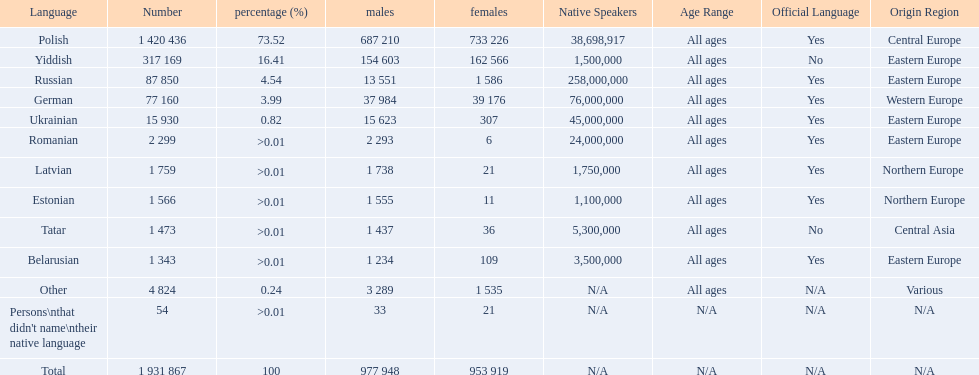How many languages are there? Polish, Yiddish, Russian, German, Ukrainian, Romanian, Latvian, Estonian, Tatar, Belarusian. Which language do more people speak? Polish. 